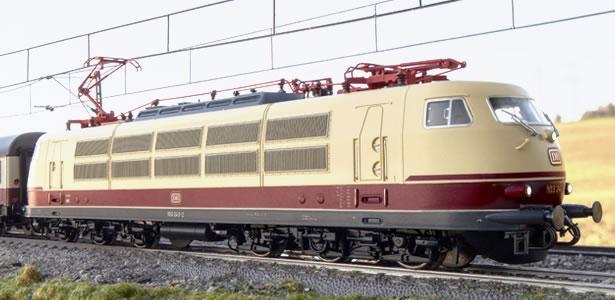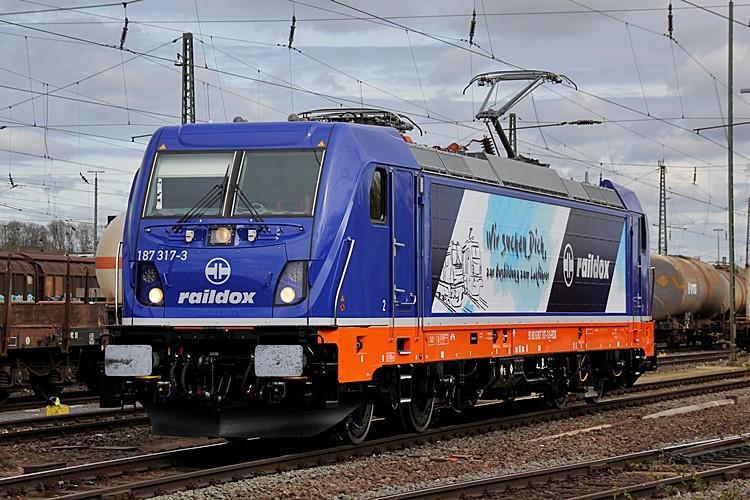The first image is the image on the left, the second image is the image on the right. Given the left and right images, does the statement "on the right side a single care is heading to the left" hold true? Answer yes or no. Yes. The first image is the image on the left, the second image is the image on the right. Evaluate the accuracy of this statement regarding the images: "In the right image, the train doesn't appear to be hauling anything.". Is it true? Answer yes or no. Yes. 